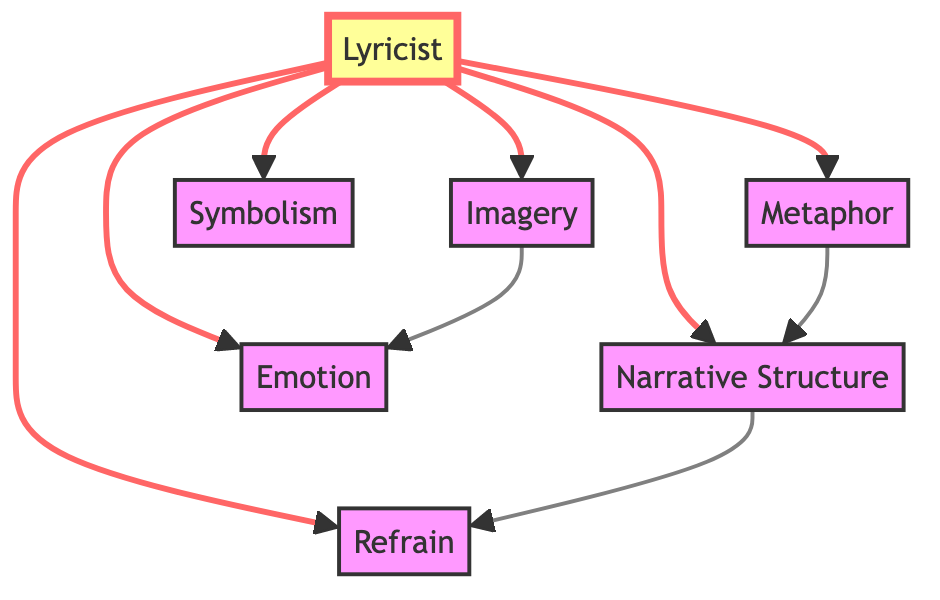What's the total number of nodes in the diagram? The diagram lists seven specific entities: "Lyricist," "Imagery," "Metaphor," "Narrative Structure," "Emotion," "Refrain," and "Symbolism." Therefore, to find the total number of nodes, we simply count these entities.
Answer: 7 How many edges are present in the diagram? The edges represent the relationships or connections between the nodes. By inspecting the diagram, we can see that there are a total of six edges connecting the "Lyricist" to the other nodes and additional edges connecting some of those nodes to each other. Counting all these connections gives us the total.
Answer: 9 Which node is the source of the edge connecting to "Emotion"? The edge from the "Lyricist" node connects directly to the "Emotion" node, indicating that the "Lyricist" influences or contributes to the emotion expressed in the lyrics.
Answer: Lyricist What is the relationship between "Imagery" and "Emotion"? In the diagram, there is a direct edge from "Imagery" to "Emotion," which shows that imagery used in lyrics is intended to evoke certain feelings or emotions in the audience.
Answer: Imagery influences Emotion Which two nodes are connected by an edge, where one is a metaphor and the other represents narrative structure? The "Metaphor" node has a direct edge connecting to the "Narrative Structure" node, indicating that metaphors play a role in shaping the story structure within a song.
Answer: Metaphor and Narrative Structure How many nodes directly connect to the "Lyricist"? The “Lyricist” has six direct connections: "Imagery," "Metaphor," "Narrative Structure," "Emotion," "Refrain," and "Symbolism." Counting these nodes gives the total number of direct connections.
Answer: 6 Which literary technique influences "Refrain"? Upon examining the edges, it's clear the node "Narrative Structure" connects directly to "Refrain," indicating that the way the story is structured affects how the refrain is crafted within a song.
Answer: Narrative Structure What is the indirect relationship chain from "Symbolism" to "Emotion"? Starting at "Symbolism," there is no direct edge to "Emotion," but if we observe the node connections, "Symbolism" indirectly influences "Emotion" through "Lyricist" and "Imagery." The connection is established by moving from "Symbolism" to the "Lyricist," then "Imagery," and finally to "Emotion."
Answer: Symbolism → Lyricist → Imagery → Emotion Which literary technique connects "Metaphor" and "Refrain"? Looking at the edges, we find that "Metaphor" connects to "Narrative Structure," and "Narrative Structure" then connects to "Refrain." Thus, the connection between them is established through narrative elements in songwriting.
Answer: Narrative Structure 